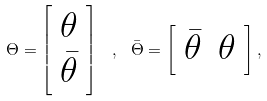<formula> <loc_0><loc_0><loc_500><loc_500>\Theta = \left [ \begin{array} { c } \theta \\ \bar { \theta } \end{array} \right ] \ , \ \bar { \Theta } = \left [ \begin{array} { c c } \bar { \theta } & \theta \end{array} \right ] ,</formula> 